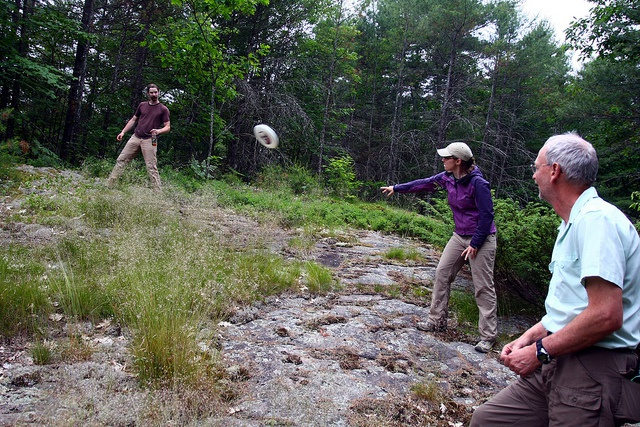Describe the objects in this image and their specific colors. I can see people in darkgreen, black, lightblue, maroon, and brown tones, people in darkgreen, black, gray, purple, and darkgray tones, people in darkgreen, black, darkgray, gray, and purple tones, and frisbee in darkgreen, darkgray, lightgray, gray, and black tones in this image. 